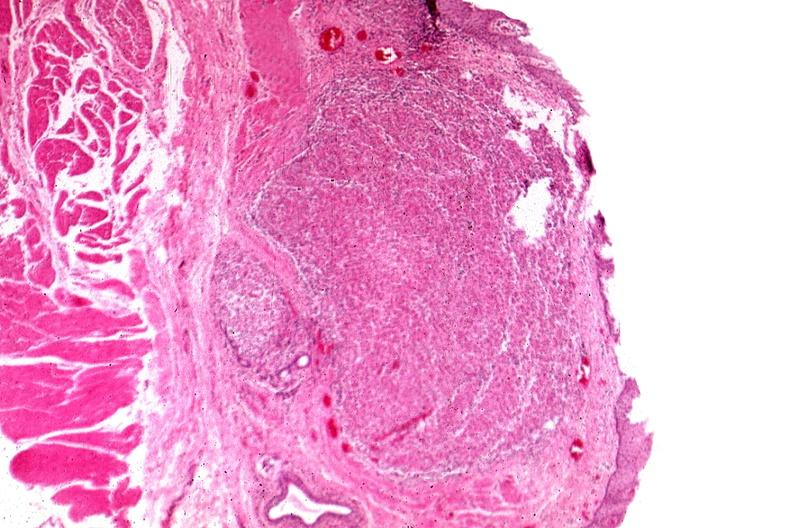s esophagus present?
Answer the question using a single word or phrase. Yes 